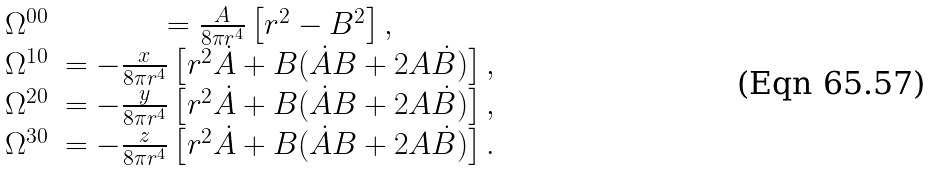Convert formula to latex. <formula><loc_0><loc_0><loc_500><loc_500>\begin{array} { c c c } \Omega ^ { 0 0 } & = \frac { A } { 8 \pi r ^ { 4 } } \left [ r ^ { 2 } - B ^ { 2 } \right ] , \\ \Omega ^ { 1 0 } & = - \frac { x } { 8 \pi r ^ { 4 } } \left [ r ^ { 2 } \dot { A } + B ( \dot { A } B + 2 A \dot { B } ) \right ] , \\ \Omega ^ { 2 0 } & = - \frac { y } { 8 \pi r ^ { 4 } } \left [ r ^ { 2 } \dot { A } + B ( \dot { A } B + 2 A \dot { B } ) \right ] , \\ \Omega ^ { 3 0 } & = - \frac { z } { 8 \pi r ^ { 4 } } \left [ r ^ { 2 } \dot { A } + B ( \dot { A } B + 2 A \dot { B } ) \right ] . \end{array}</formula> 